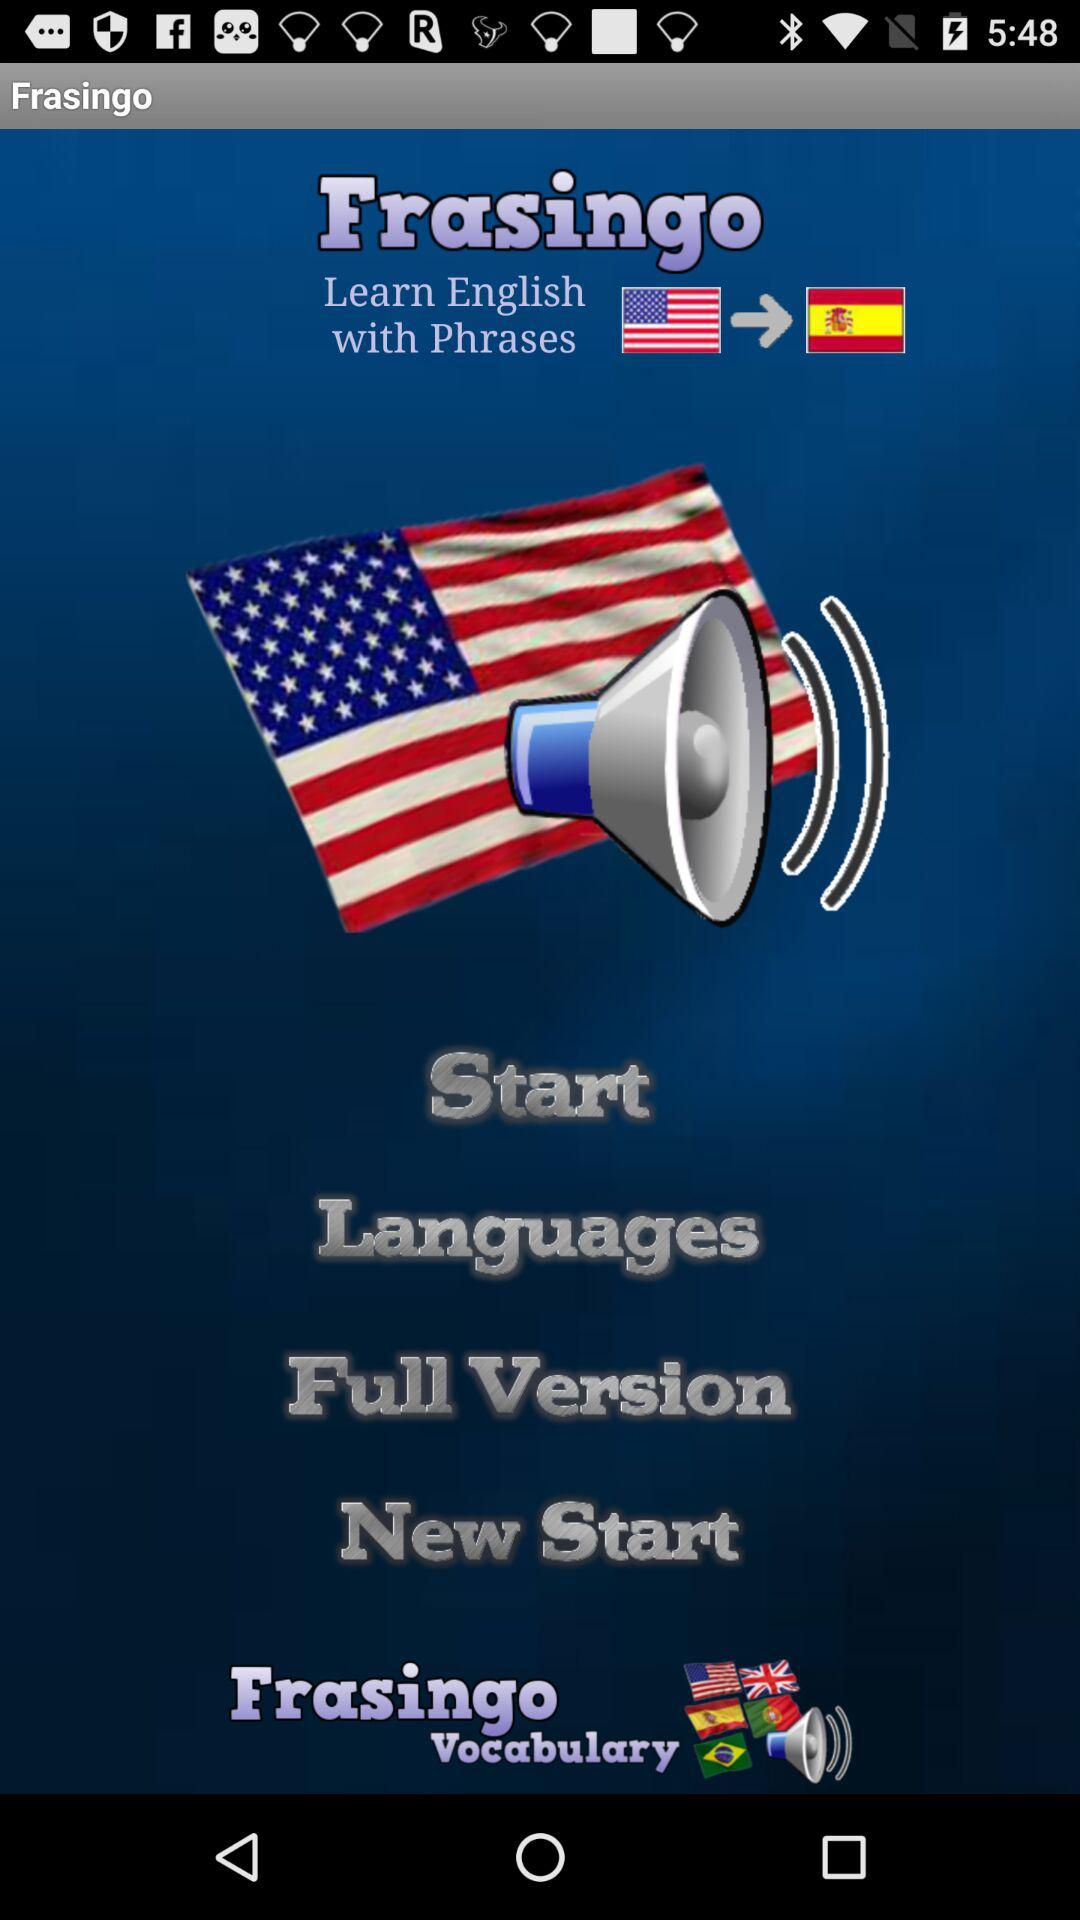What is the application name? The application name is "Frasingo". 